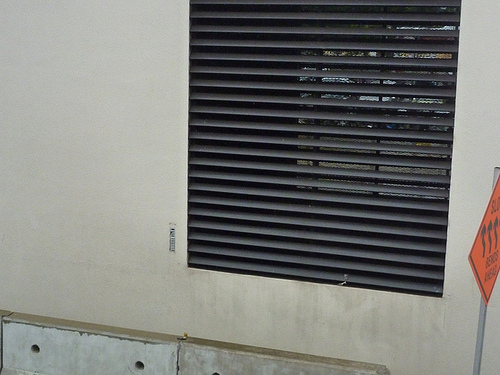<image>
Can you confirm if the window is on the wall? No. The window is not positioned on the wall. They may be near each other, but the window is not supported by or resting on top of the wall. 